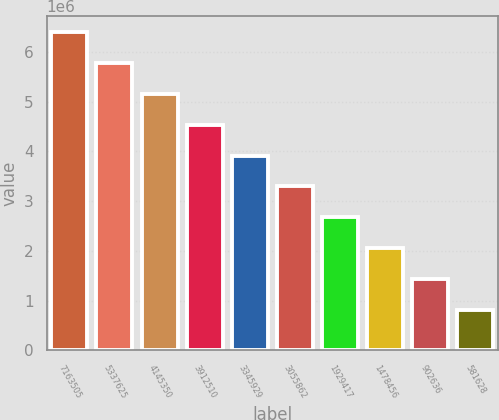Convert chart. <chart><loc_0><loc_0><loc_500><loc_500><bar_chart><fcel>7163505<fcel>5337625<fcel>4145350<fcel>3912510<fcel>3345929<fcel>3055862<fcel>1929417<fcel>1478456<fcel>902636<fcel>581628<nl><fcel>6.39445e+06<fcel>5.77428e+06<fcel>5.15411e+06<fcel>4.53394e+06<fcel>3.91377e+06<fcel>3.29361e+06<fcel>2.67344e+06<fcel>2.05327e+06<fcel>1.4331e+06<fcel>812934<nl></chart> 